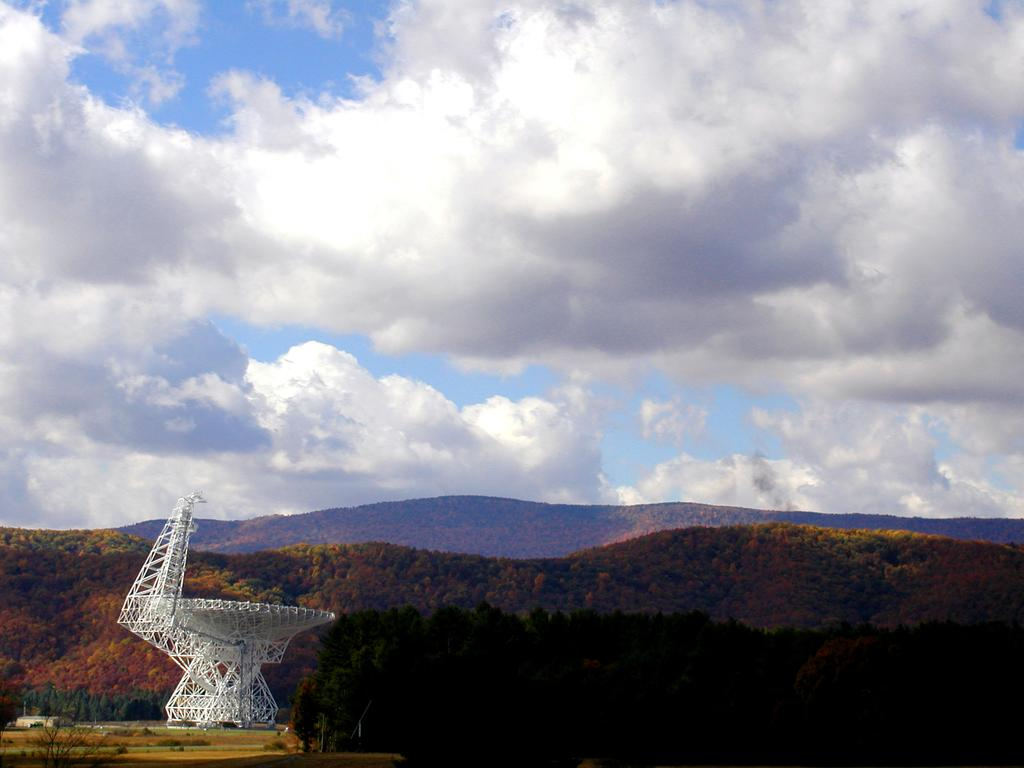What is the main structure in the image? There is a tower in the image. What color is the tower? The tower is white in color. What can be seen in the background of the image? There are trees in the background of the image. How would you describe the sky in the image? The sky is cloudy in the image. What type of flesh can be seen hanging from the tower in the image? There is no flesh present in the image; the tower is white and made of a solid material. How much dust can be seen accumulating on the tower in the image? There is no dust visible on the tower in the image; it appears clean and well-maintained. 